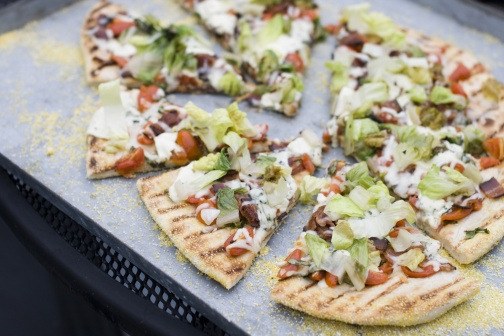If this pizza could talk, what would it say about its creation? If this pizza could talk, it might say, 'I am the result of passion and creativity! From the farm-fresh lettuce and vine-ripened tomatoes to the creamy, golden-brown cheese, every ingredient was chosen with care. My dough was kneaded with love, and I was baked to perfection, bringing out the best in each component. I am more than just a meal; I am a celebration of the artistry and joy that comes with creating and sharing good food.' 